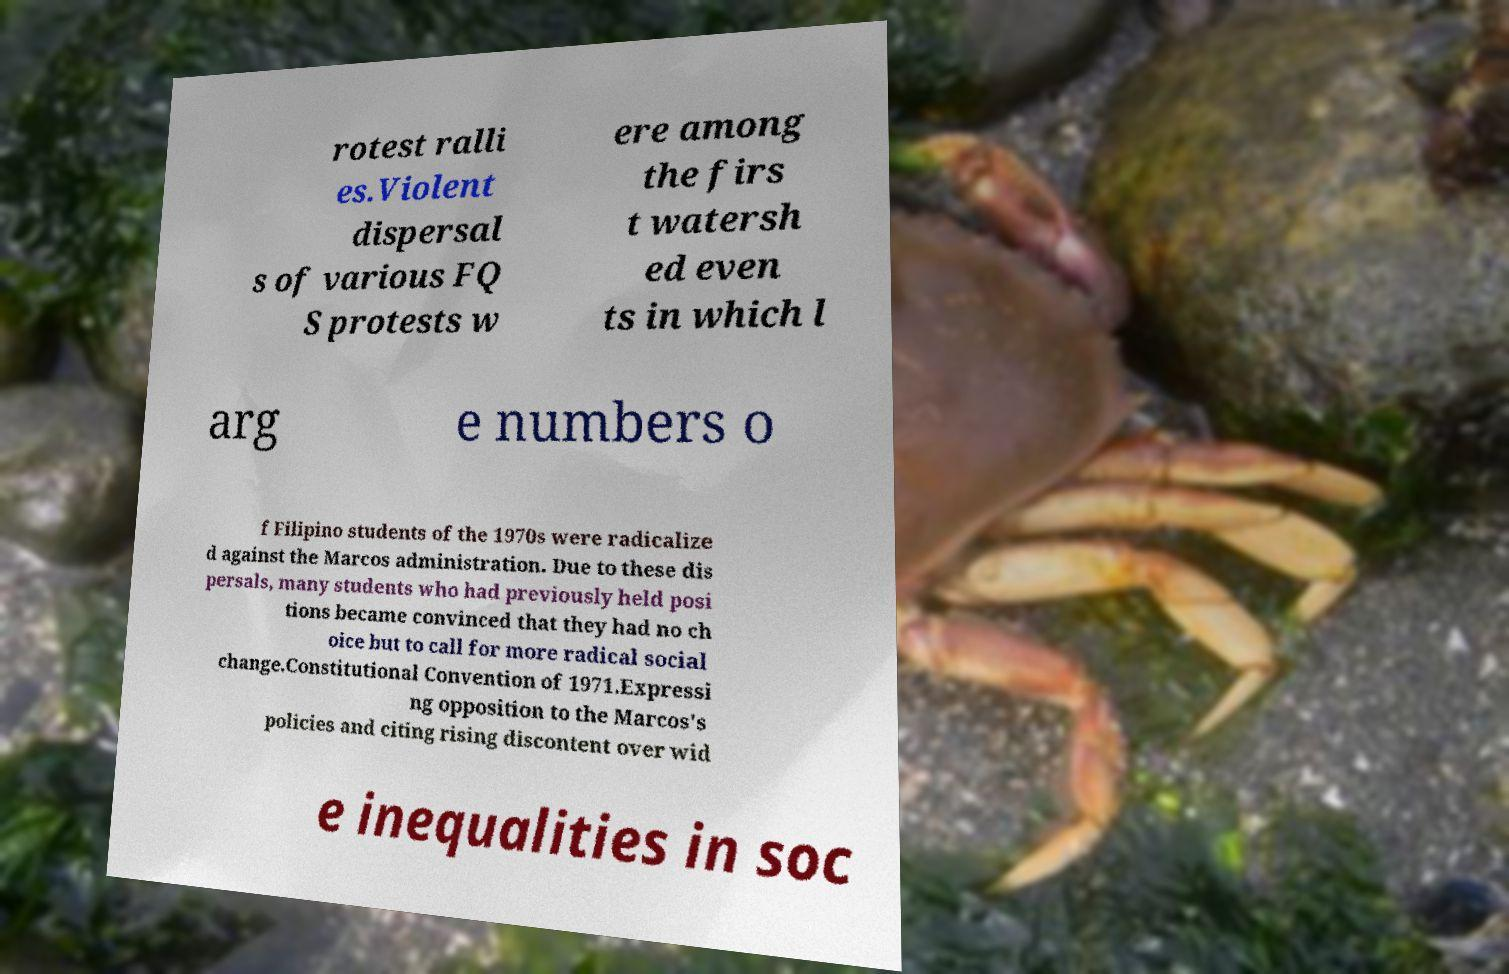There's text embedded in this image that I need extracted. Can you transcribe it verbatim? rotest ralli es.Violent dispersal s of various FQ S protests w ere among the firs t watersh ed even ts in which l arg e numbers o f Filipino students of the 1970s were radicalize d against the Marcos administration. Due to these dis persals, many students who had previously held posi tions became convinced that they had no ch oice but to call for more radical social change.Constitutional Convention of 1971.Expressi ng opposition to the Marcos's policies and citing rising discontent over wid e inequalities in soc 